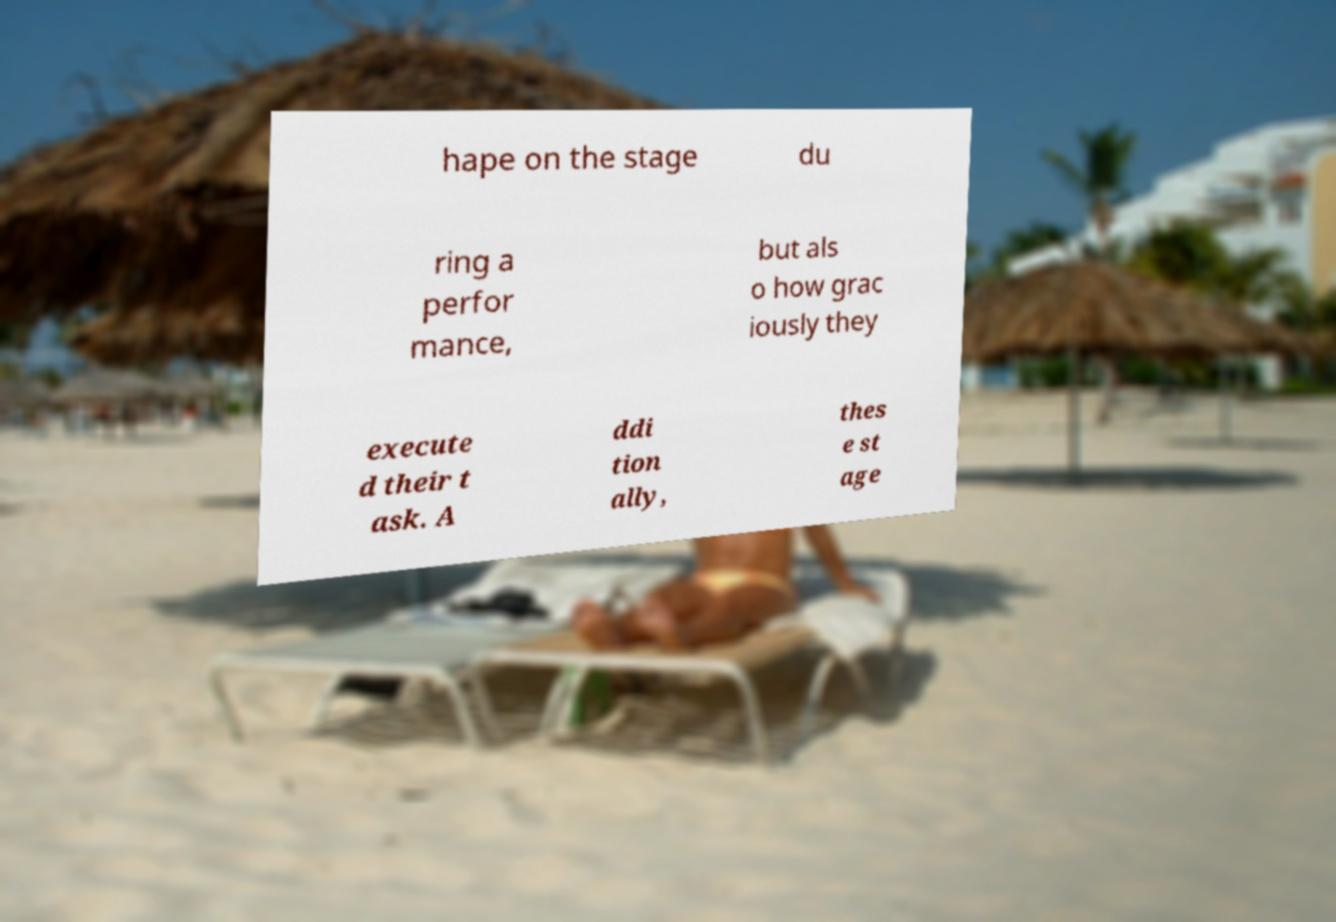For documentation purposes, I need the text within this image transcribed. Could you provide that? hape on the stage du ring a perfor mance, but als o how grac iously they execute d their t ask. A ddi tion ally, thes e st age 